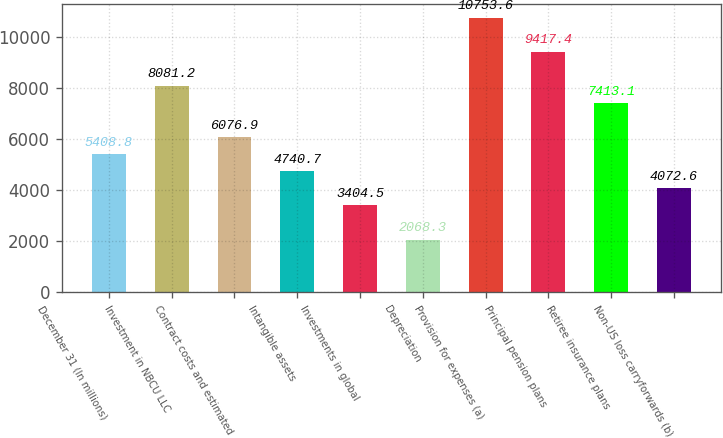Convert chart to OTSL. <chart><loc_0><loc_0><loc_500><loc_500><bar_chart><fcel>December 31 (In millions)<fcel>Investment in NBCU LLC<fcel>Contract costs and estimated<fcel>Intangible assets<fcel>Investments in global<fcel>Depreciation<fcel>Provision for expenses (a)<fcel>Principal pension plans<fcel>Retiree insurance plans<fcel>Non-US loss carryforwards (b)<nl><fcel>5408.8<fcel>8081.2<fcel>6076.9<fcel>4740.7<fcel>3404.5<fcel>2068.3<fcel>10753.6<fcel>9417.4<fcel>7413.1<fcel>4072.6<nl></chart> 